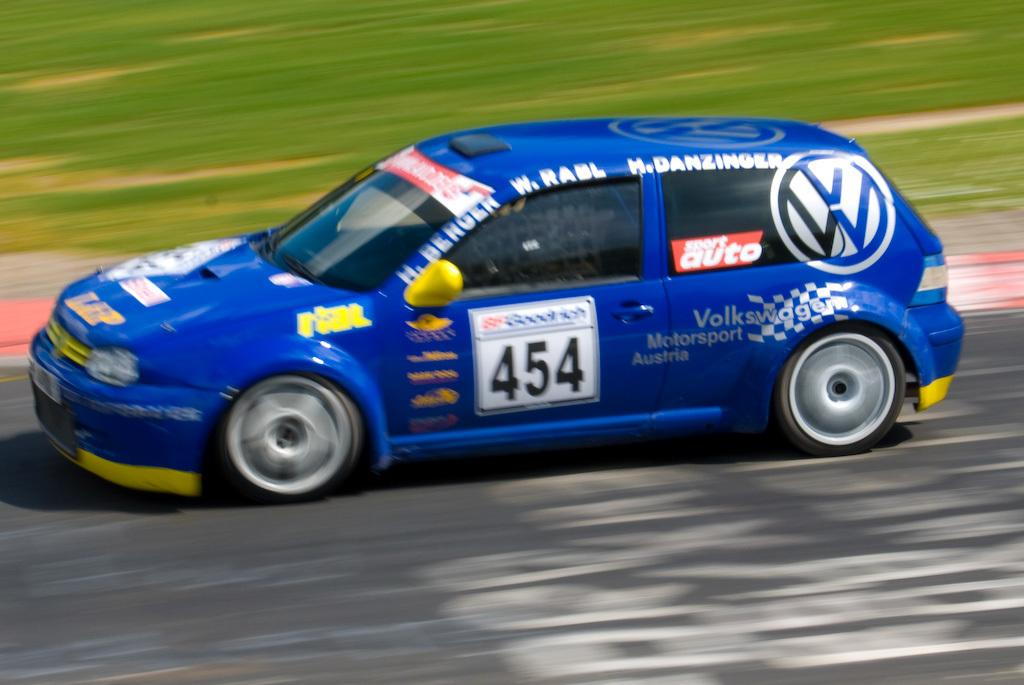What is the main subject of the image? There is a vehicle in the image. Where is the vehicle located? The vehicle is on the road. What color is the vehicle? The vehicle is blue in color. What can be seen in the background of the image? There is grass visible in the background of the image. What type of wax is being used to polish the vehicle in the image? There is no indication in the image that wax is being used to polish the vehicle, and therefore no such activity can be observed. 